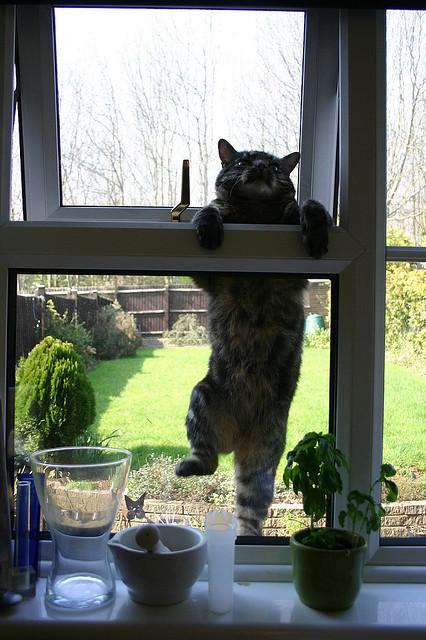What is climbing in the window?
Short answer required. Cat. Is it a sunny day?
Answer briefly. Yes. Is there a plant on the window ledge?
Answer briefly. Yes. 